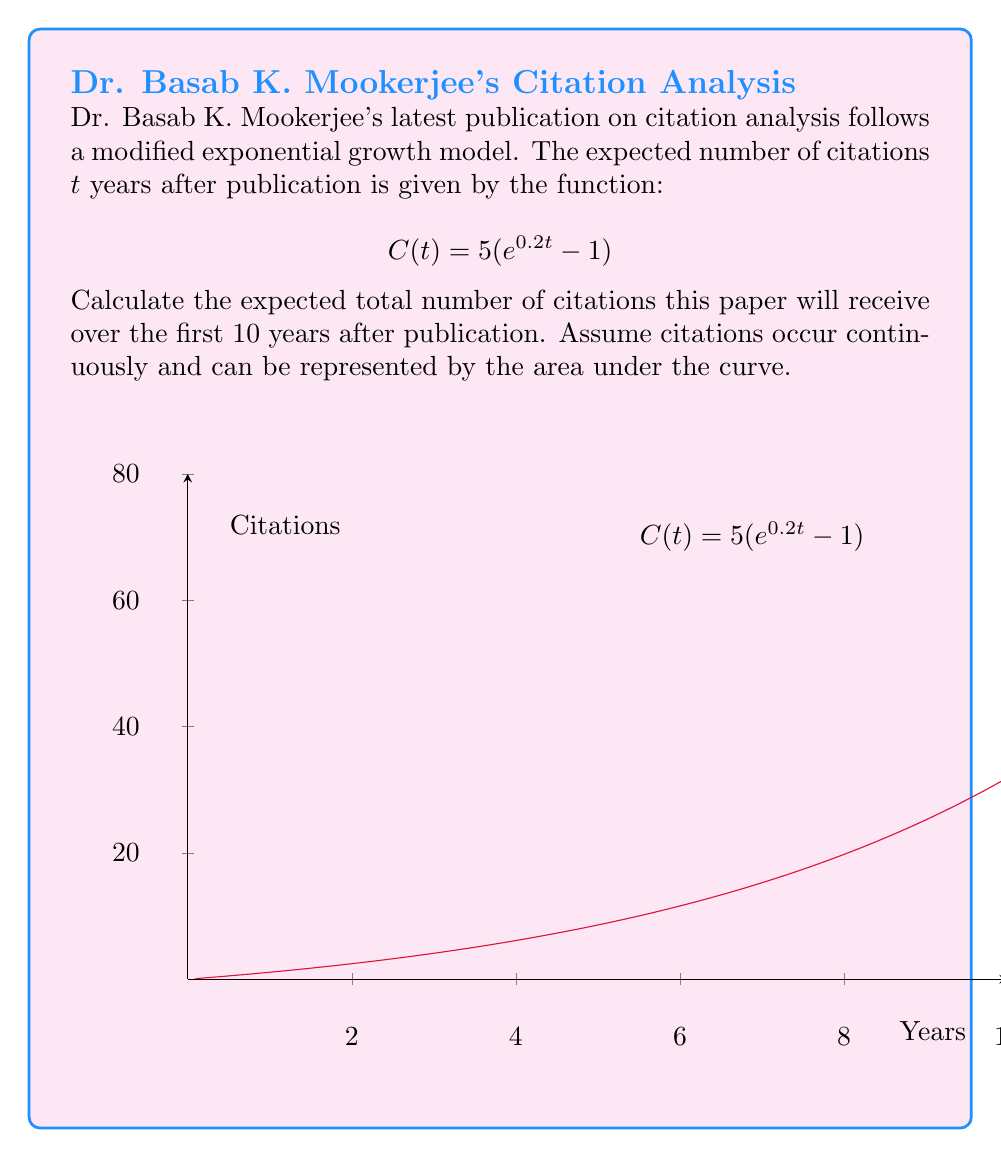Can you answer this question? To find the total number of citations over 10 years, we need to calculate the area under the curve $C(t) = 5(e^{0.2t} - 1)$ from $t=0$ to $t=10$. This can be done using definite integration:

1) Set up the integral:
   $$\int_0^{10} 5(e^{0.2t} - 1) dt$$

2) Integrate:
   $$5[\frac{1}{0.2}e^{0.2t} - t]_0^{10}$$

3) Evaluate the integral:
   $$5[(\frac{1}{0.2}e^{0.2(10)} - 10) - (\frac{1}{0.2}e^{0.2(0)} - 0)]$$
   
   $$= 5[(\frac{1}{0.2}e^2 - 10) - (\frac{1}{0.2} - 0)]$$

4) Simplify:
   $$= 5[\frac{e^2}{0.2} - 10 - 5]$$
   
   $$= 5[\frac{e^2}{0.2} - 15]$$
   
   $$= 25e^2 - 75$$

5) Calculate the final value:
   $$\approx 185.91$$

Therefore, the expected total number of citations over the first 10 years is approximately 185.91.
Answer: 185.91 citations 